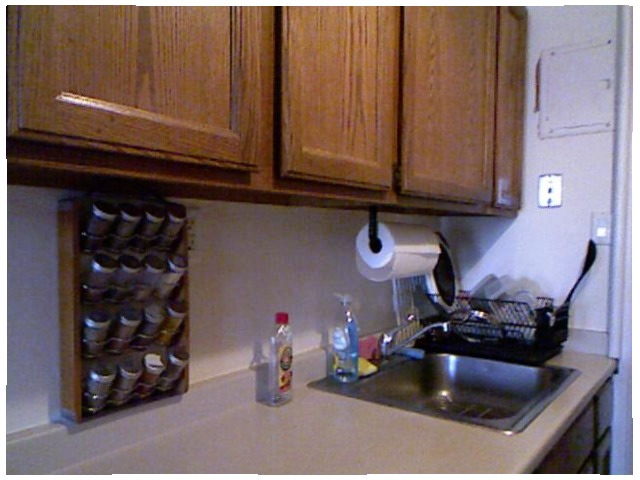<image>
Is there a stain on the cabinet? Yes. Looking at the image, I can see the stain is positioned on top of the cabinet, with the cabinet providing support. Is there a paper on the wall? No. The paper is not positioned on the wall. They may be near each other, but the paper is not supported by or resting on top of the wall. Where is the added powder in relation to the bottle? Is it to the right of the bottle? No. The added powder is not to the right of the bottle. The horizontal positioning shows a different relationship. Is there a tissue paper above the wash basin? Yes. The tissue paper is positioned above the wash basin in the vertical space, higher up in the scene. 